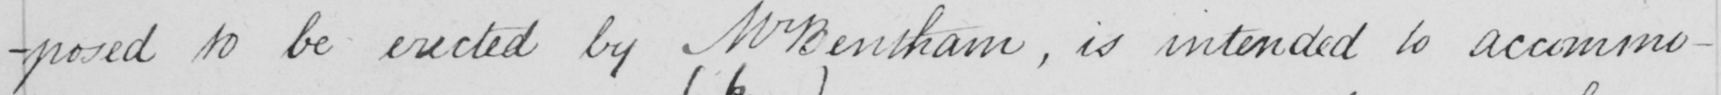What text is written in this handwritten line? -posed to be erected by Mr Bentham , is intended to accommo- 